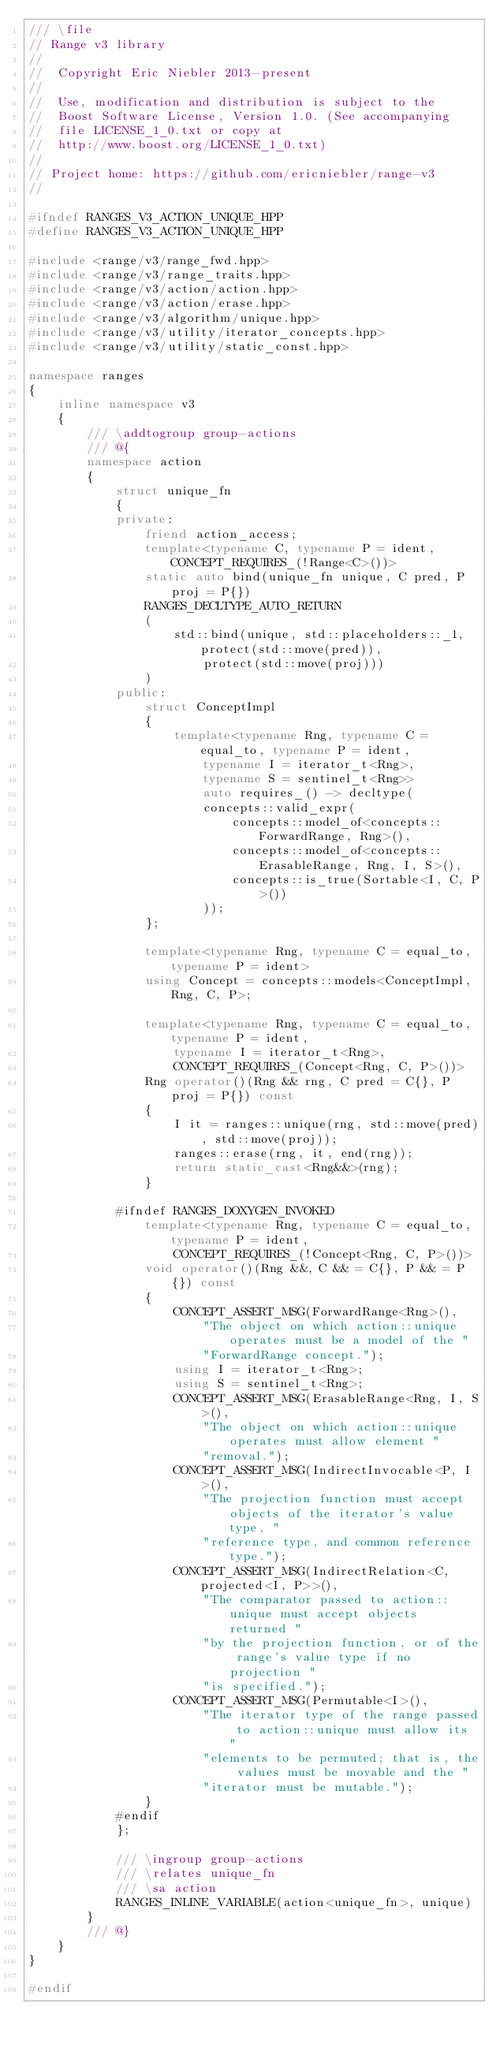Convert code to text. <code><loc_0><loc_0><loc_500><loc_500><_C++_>/// \file
// Range v3 library
//
//  Copyright Eric Niebler 2013-present
//
//  Use, modification and distribution is subject to the
//  Boost Software License, Version 1.0. (See accompanying
//  file LICENSE_1_0.txt or copy at
//  http://www.boost.org/LICENSE_1_0.txt)
//
// Project home: https://github.com/ericniebler/range-v3
//

#ifndef RANGES_V3_ACTION_UNIQUE_HPP
#define RANGES_V3_ACTION_UNIQUE_HPP

#include <range/v3/range_fwd.hpp>
#include <range/v3/range_traits.hpp>
#include <range/v3/action/action.hpp>
#include <range/v3/action/erase.hpp>
#include <range/v3/algorithm/unique.hpp>
#include <range/v3/utility/iterator_concepts.hpp>
#include <range/v3/utility/static_const.hpp>

namespace ranges
{
    inline namespace v3
    {
        /// \addtogroup group-actions
        /// @{
        namespace action
        {
            struct unique_fn
            {
            private:
                friend action_access;
                template<typename C, typename P = ident, CONCEPT_REQUIRES_(!Range<C>())>
                static auto bind(unique_fn unique, C pred, P proj = P{})
                RANGES_DECLTYPE_AUTO_RETURN
                (
                    std::bind(unique, std::placeholders::_1, protect(std::move(pred)),
                        protect(std::move(proj)))
                )
            public:
                struct ConceptImpl
                {
                    template<typename Rng, typename C = equal_to, typename P = ident,
                        typename I = iterator_t<Rng>,
                        typename S = sentinel_t<Rng>>
                        auto requires_() -> decltype(
                        concepts::valid_expr(
                            concepts::model_of<concepts::ForwardRange, Rng>(),
                            concepts::model_of<concepts::ErasableRange, Rng, I, S>(),
                            concepts::is_true(Sortable<I, C, P>())
                        ));
                };

                template<typename Rng, typename C = equal_to, typename P = ident>
                using Concept = concepts::models<ConceptImpl, Rng, C, P>;

                template<typename Rng, typename C = equal_to, typename P = ident,
                    typename I = iterator_t<Rng>,
                    CONCEPT_REQUIRES_(Concept<Rng, C, P>())>
                Rng operator()(Rng && rng, C pred = C{}, P proj = P{}) const
                {
                    I it = ranges::unique(rng, std::move(pred), std::move(proj));
                    ranges::erase(rng, it, end(rng));
                    return static_cast<Rng&&>(rng);
                }

            #ifndef RANGES_DOXYGEN_INVOKED
                template<typename Rng, typename C = equal_to, typename P = ident,
                    CONCEPT_REQUIRES_(!Concept<Rng, C, P>())>
                void operator()(Rng &&, C && = C{}, P && = P{}) const
                {
                    CONCEPT_ASSERT_MSG(ForwardRange<Rng>(),
                        "The object on which action::unique operates must be a model of the "
                        "ForwardRange concept.");
                    using I = iterator_t<Rng>;
                    using S = sentinel_t<Rng>;
                    CONCEPT_ASSERT_MSG(ErasableRange<Rng, I, S>(),
                        "The object on which action::unique operates must allow element "
                        "removal.");
                    CONCEPT_ASSERT_MSG(IndirectInvocable<P, I>(),
                        "The projection function must accept objects of the iterator's value type, "
                        "reference type, and common reference type.");
                    CONCEPT_ASSERT_MSG(IndirectRelation<C, projected<I, P>>(),
                        "The comparator passed to action::unique must accept objects returned "
                        "by the projection function, or of the range's value type if no projection "
                        "is specified.");
                    CONCEPT_ASSERT_MSG(Permutable<I>(),
                        "The iterator type of the range passed to action::unique must allow its "
                        "elements to be permuted; that is, the values must be movable and the "
                        "iterator must be mutable.");
                }
            #endif
            };

            /// \ingroup group-actions
            /// \relates unique_fn
            /// \sa action
            RANGES_INLINE_VARIABLE(action<unique_fn>, unique)
        }
        /// @}
    }
}

#endif
</code> 